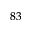<formula> <loc_0><loc_0><loc_500><loc_500>^ { 8 3 }</formula> 